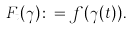<formula> <loc_0><loc_0><loc_500><loc_500>F _ { t } ( \gamma ) \colon = f ( \gamma ( t ) ) .</formula> 